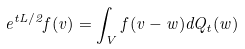Convert formula to latex. <formula><loc_0><loc_0><loc_500><loc_500>e ^ { t L / 2 } f ( v ) = \int _ { V } f ( v - w ) d Q _ { t } ( w )</formula> 